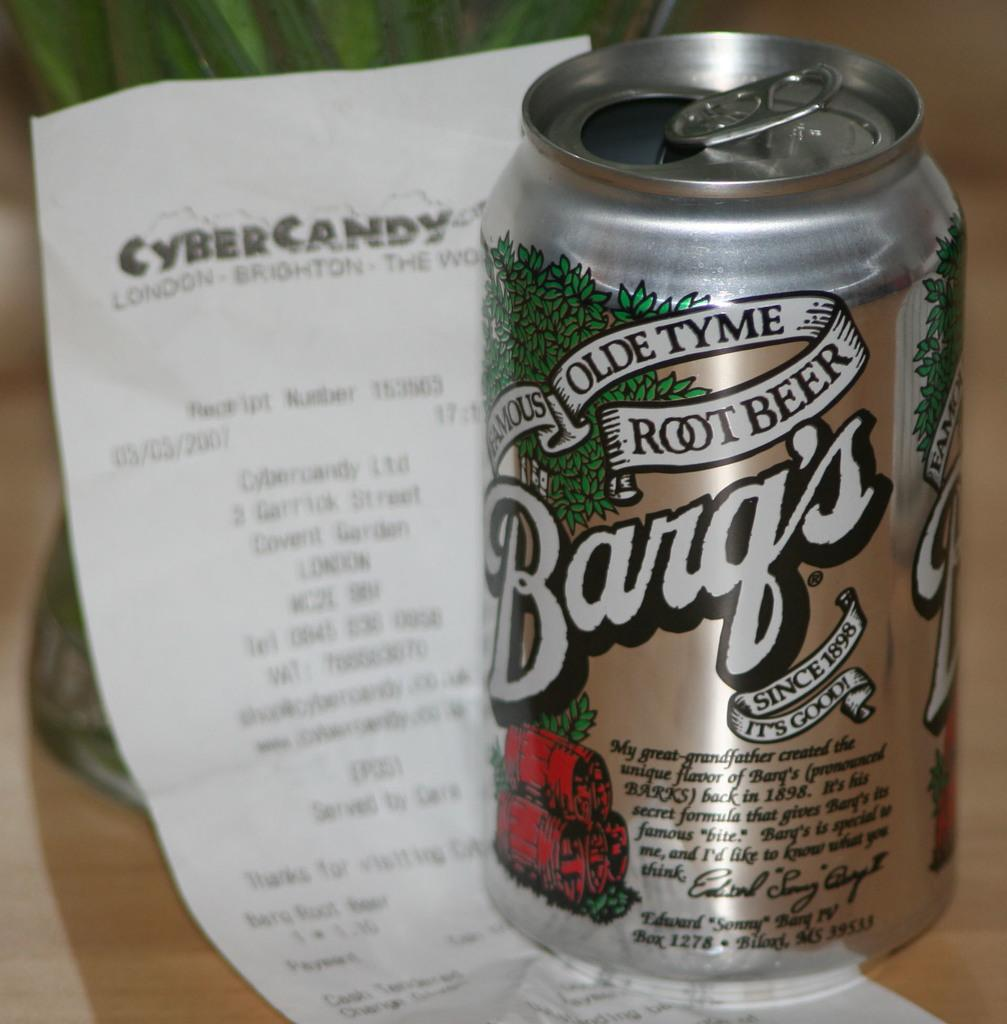<image>
Render a clear and concise summary of the photo. A can of Barq's root beer sits on top of a Cyber Candy receipt. 